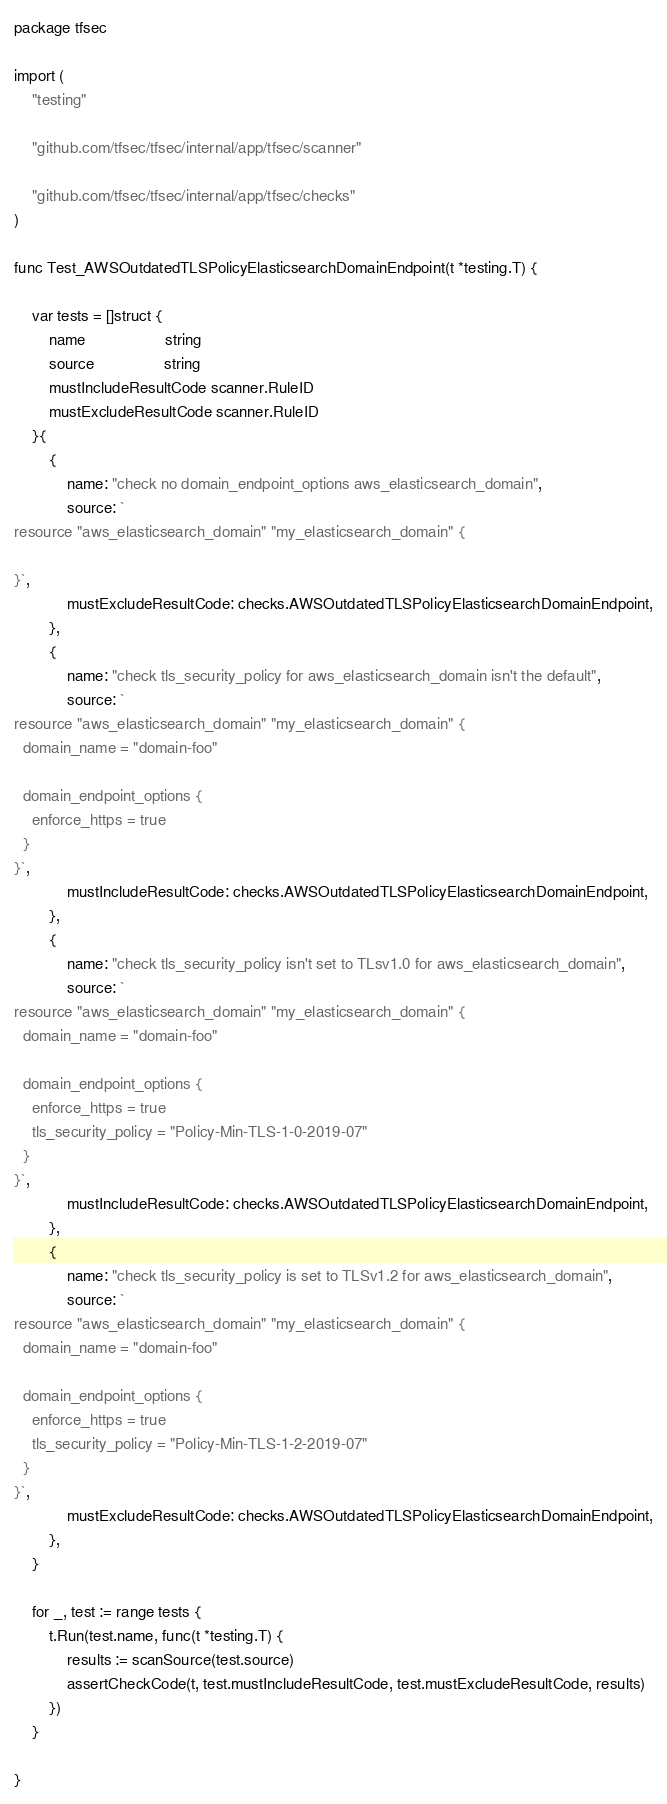Convert code to text. <code><loc_0><loc_0><loc_500><loc_500><_Go_>package tfsec

import (
	"testing"

	"github.com/tfsec/tfsec/internal/app/tfsec/scanner"

	"github.com/tfsec/tfsec/internal/app/tfsec/checks"
)

func Test_AWSOutdatedTLSPolicyElasticsearchDomainEndpoint(t *testing.T) {

	var tests = []struct {
		name                  string
		source                string
		mustIncludeResultCode scanner.RuleID
		mustExcludeResultCode scanner.RuleID
	}{
		{
			name: "check no domain_endpoint_options aws_elasticsearch_domain",
			source: `
resource "aws_elasticsearch_domain" "my_elasticsearch_domain" {
	
}`,
			mustExcludeResultCode: checks.AWSOutdatedTLSPolicyElasticsearchDomainEndpoint,
		},
		{
			name: "check tls_security_policy for aws_elasticsearch_domain isn't the default",
			source: `
resource "aws_elasticsearch_domain" "my_elasticsearch_domain" {
  domain_name = "domain-foo"

  domain_endpoint_options {
    enforce_https = true
  }
}`,
			mustIncludeResultCode: checks.AWSOutdatedTLSPolicyElasticsearchDomainEndpoint,
		},
		{
			name: "check tls_security_policy isn't set to TLsv1.0 for aws_elasticsearch_domain",
			source: `
resource "aws_elasticsearch_domain" "my_elasticsearch_domain" {
  domain_name = "domain-foo"

  domain_endpoint_options {
    enforce_https = true
    tls_security_policy = "Policy-Min-TLS-1-0-2019-07"
  }
}`,
			mustIncludeResultCode: checks.AWSOutdatedTLSPolicyElasticsearchDomainEndpoint,
		},
		{
			name: "check tls_security_policy is set to TLSv1.2 for aws_elasticsearch_domain",
			source: `
resource "aws_elasticsearch_domain" "my_elasticsearch_domain" {
  domain_name = "domain-foo"

  domain_endpoint_options {
    enforce_https = true
    tls_security_policy = "Policy-Min-TLS-1-2-2019-07"
  }
}`,
			mustExcludeResultCode: checks.AWSOutdatedTLSPolicyElasticsearchDomainEndpoint,
		},
	}

	for _, test := range tests {
		t.Run(test.name, func(t *testing.T) {
			results := scanSource(test.source)
			assertCheckCode(t, test.mustIncludeResultCode, test.mustExcludeResultCode, results)
		})
	}

}
</code> 